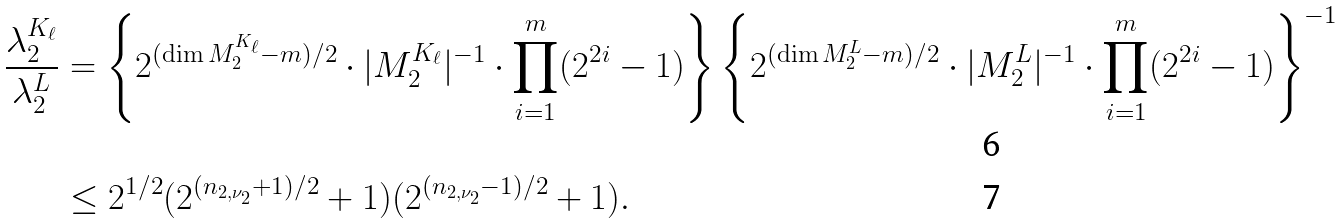<formula> <loc_0><loc_0><loc_500><loc_500>\frac { \lambda _ { 2 } ^ { K _ { \ell } } } { \lambda _ { 2 } ^ { L } } & = \left \{ 2 ^ { ( \dim M _ { 2 } ^ { K _ { \ell } } - m ) / 2 } \cdot | M _ { 2 } ^ { K _ { \ell } } | ^ { - 1 } \cdot \prod _ { i = 1 } ^ { m } ( 2 ^ { 2 i } - 1 ) \right \} \left \{ 2 ^ { ( \dim M _ { 2 } ^ { L } - m ) / 2 } \cdot | M _ { 2 } ^ { L } | ^ { - 1 } \cdot \prod _ { i = 1 } ^ { m } ( 2 ^ { 2 i } - 1 ) \right \} ^ { - 1 } \\ & \leq 2 ^ { 1 / 2 } ( 2 ^ { ( n _ { 2 , \nu _ { 2 } } + 1 ) / 2 } + 1 ) ( 2 ^ { ( n _ { 2 , \nu _ { 2 } } - 1 ) / 2 } + 1 ) .</formula> 